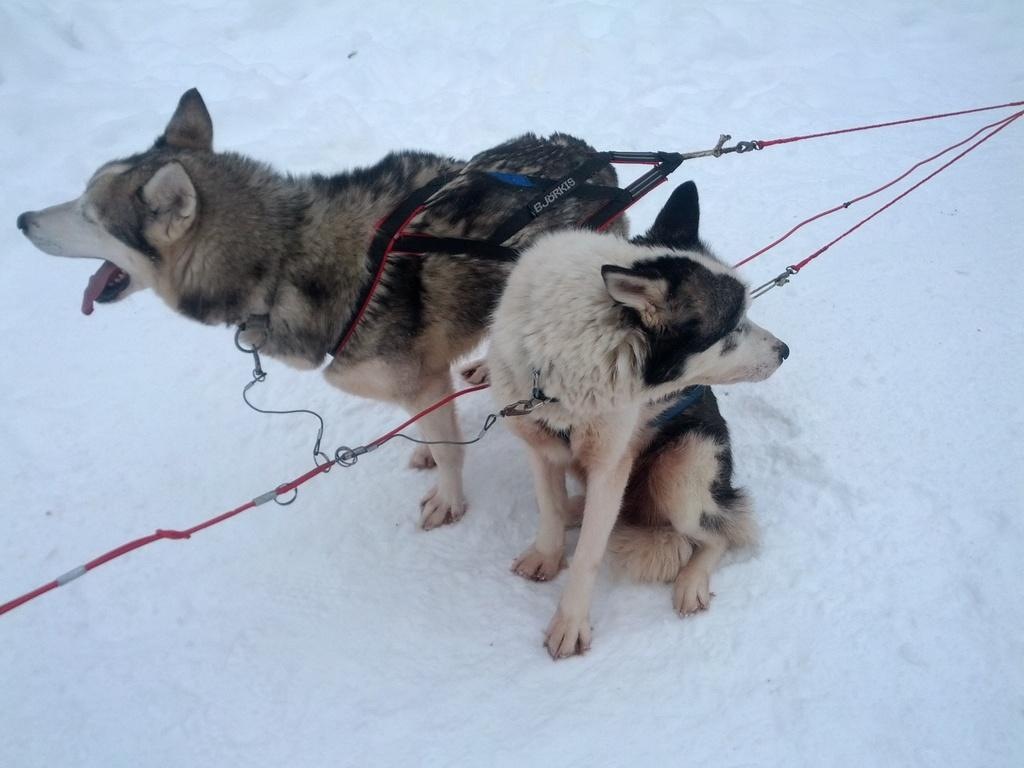How many dogs are present in the image? There are two dogs in the image. What is the setting of the image? The dogs are in the snow. What can be seen around the necks of the dogs? There are dog chains on the necks of the dogs. What type of harmony can be heard between the dogs in the image? There is no sound or indication of harmony between the dogs in the image. 